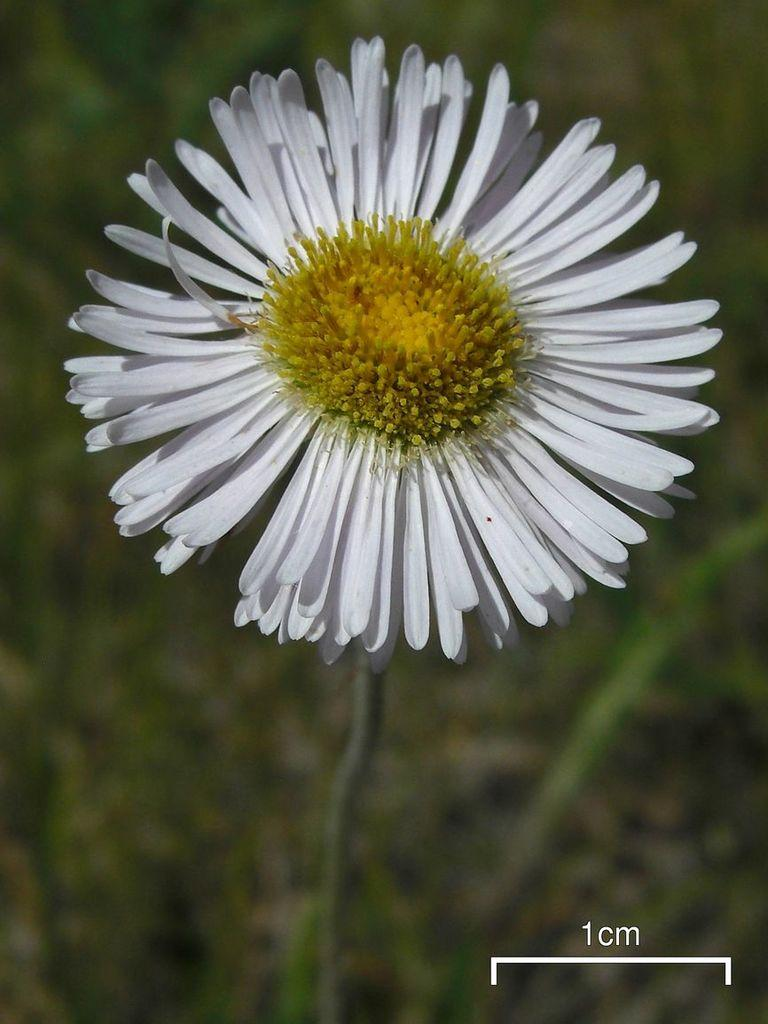What type of plant is visible in the image? There is a flower in the image. What type of neck accessory is visible in the image? There is no neck accessory present in the image; it only features a flower. What type of lumber is visible in the image? There is no lumber present in the image; it only features a flower. 